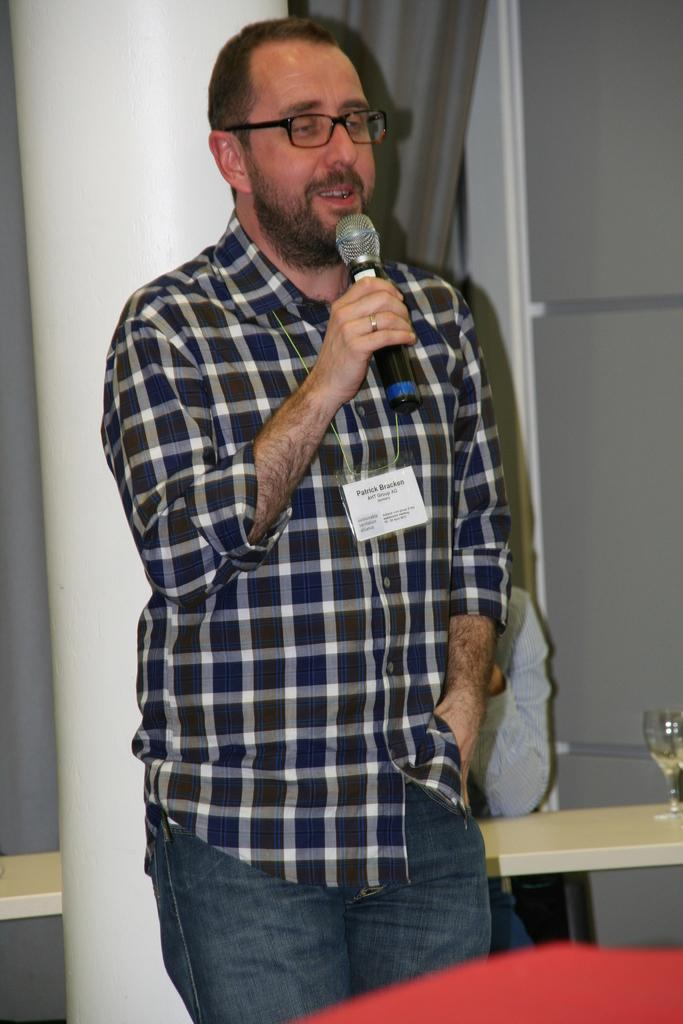What is the person in the image doing? The person is standing and holding a microphone. Can you describe the setting of the image? There is another person sitting in the background, and there is a wine glass and a curtain in the background as well. What might the person holding the microphone be doing? The person holding the microphone might be giving a speech or performing. What type of sun can be seen providing shade in the image? There is no sun present in the image, and therefore no shade can be provided by it. 